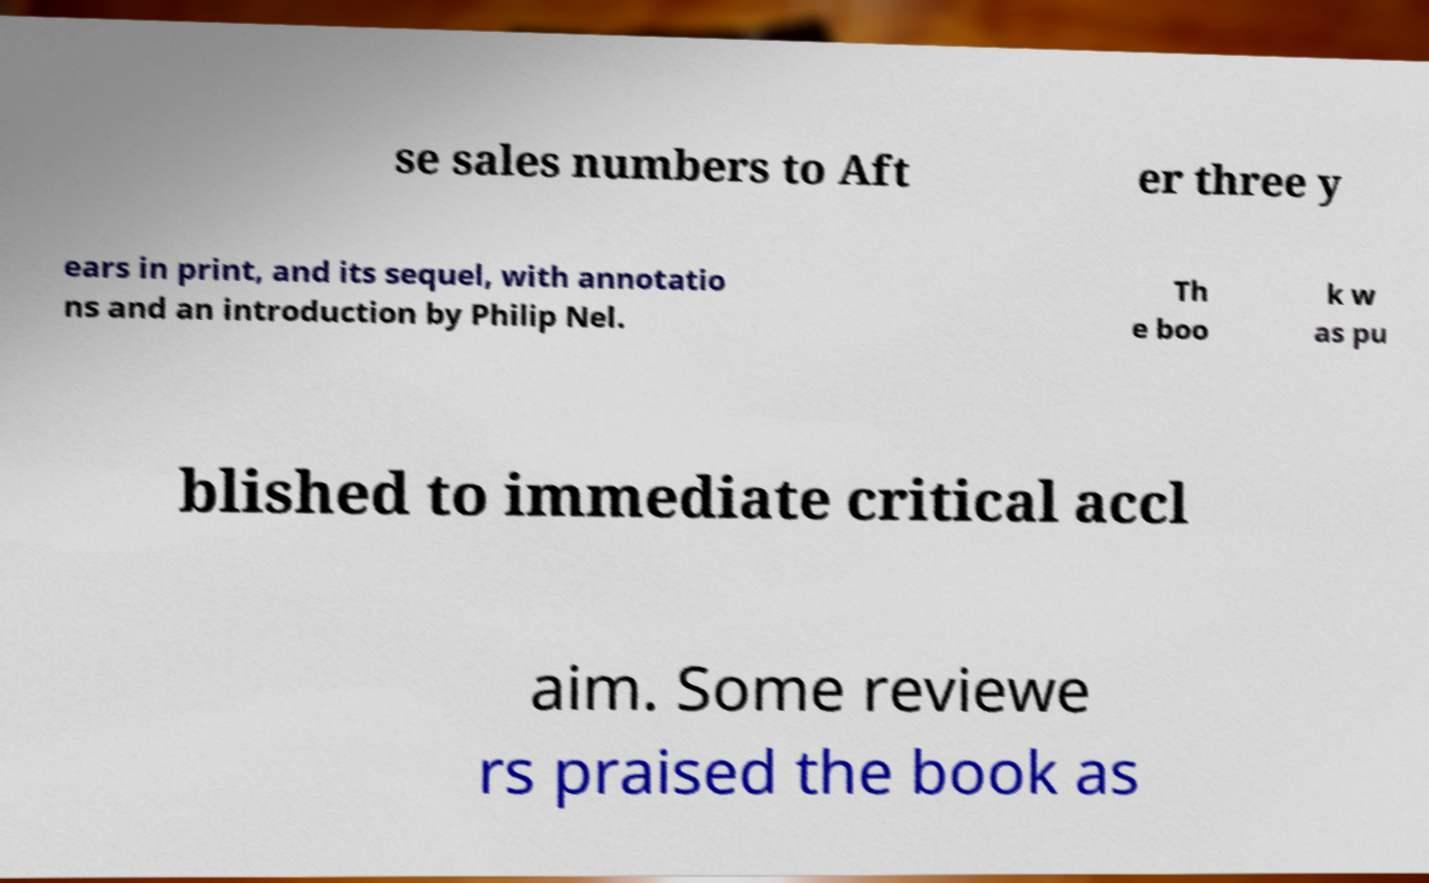Could you extract and type out the text from this image? se sales numbers to Aft er three y ears in print, and its sequel, with annotatio ns and an introduction by Philip Nel. Th e boo k w as pu blished to immediate critical accl aim. Some reviewe rs praised the book as 